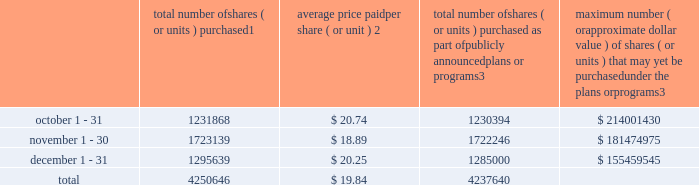Sales of unregistered securities not applicable .
Repurchases of equity securities the table provides information regarding our purchases of our equity securities during the period from october 1 , 2017 to december 31 , 2017 .
Total number of shares ( or units ) purchased 1 average price paid per share ( or unit ) 2 total number of shares ( or units ) purchased as part of publicly announced plans or programs 3 maximum number ( or approximate dollar value ) of shares ( or units ) that may yet be purchased under the plans or programs 3 .
1 included shares of our common stock , par value $ 0.10 per share , withheld under the terms of grants under employee stock-based compensation plans to offset tax withholding obligations that occurred upon vesting and release of restricted shares ( the 201cwithheld shares 201d ) .
We repurchased 1474 withheld shares in october 2017 , 893 withheld shares in november 2017 and 10639 withheld shares in december 2017 , for a total of 13006 withheld shares during the three-month period .
2 the average price per share for each of the months in the fiscal quarter and for the three-month period was calculated by dividing the sum of the applicable period of the aggregate value of the tax withholding obligations and the aggregate amount we paid for shares acquired under our share repurchase program , described in note 5 to the consolidated financial statements , by the sum of the number of withheld shares and the number of shares acquired in our share repurchase program .
3 in february 2017 , the board authorized a share repurchase program to repurchase from time to time up to $ 300.0 million , excluding fees , of our common stock ( the 201c2017 share repurchase program 201d ) .
On february 14 , 2018 , we announced that our board had approved a new share repurchase program to repurchase from time to time up to $ 300.0 million , excluding fees , of our common stock .
The new authorization is in addition to any amounts remaining for repurchase under the 2017 share repurchase program .
There is no expiration date associated with the share repurchase programs. .
What portion of the total repurchase of share has occurred during november? 
Computations: (1723139 / 4250646)
Answer: 0.40538. 